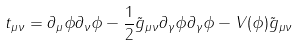<formula> <loc_0><loc_0><loc_500><loc_500>t _ { \mu \nu } = \partial _ { \mu } \phi \partial _ { \nu } \phi - \frac { 1 } { 2 } \tilde { g } _ { \mu \nu } \partial _ { \gamma } \phi \partial _ { \gamma } \phi - V ( \phi ) \tilde { g } _ { \mu \nu }</formula> 